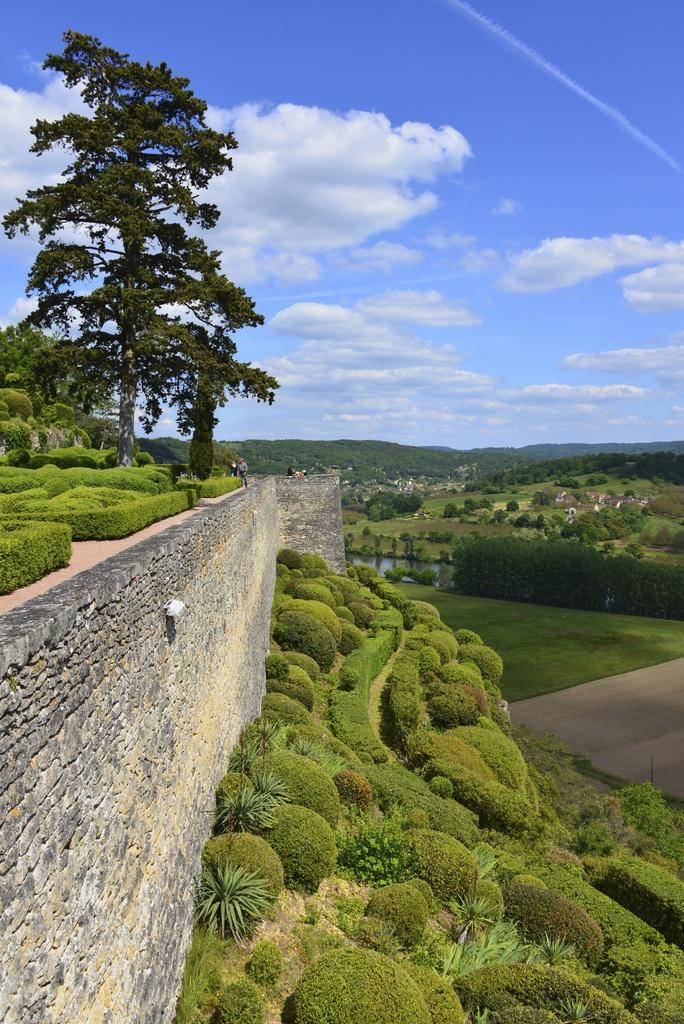What is located on the left side of the image? There is a wall on the left side of the image. What type of vegetation can be seen in the image? There are plants and trees in the image. What can be seen in the sky in the background of the image? There are clouds visible in the sky in the background of the image. What type of peace symbol can be seen on the wall in the image? There is no peace symbol present on the wall in the image. What is the slope of the ground in the image? The image does not show any slope or change in elevation; it appears to be a flat surface. 